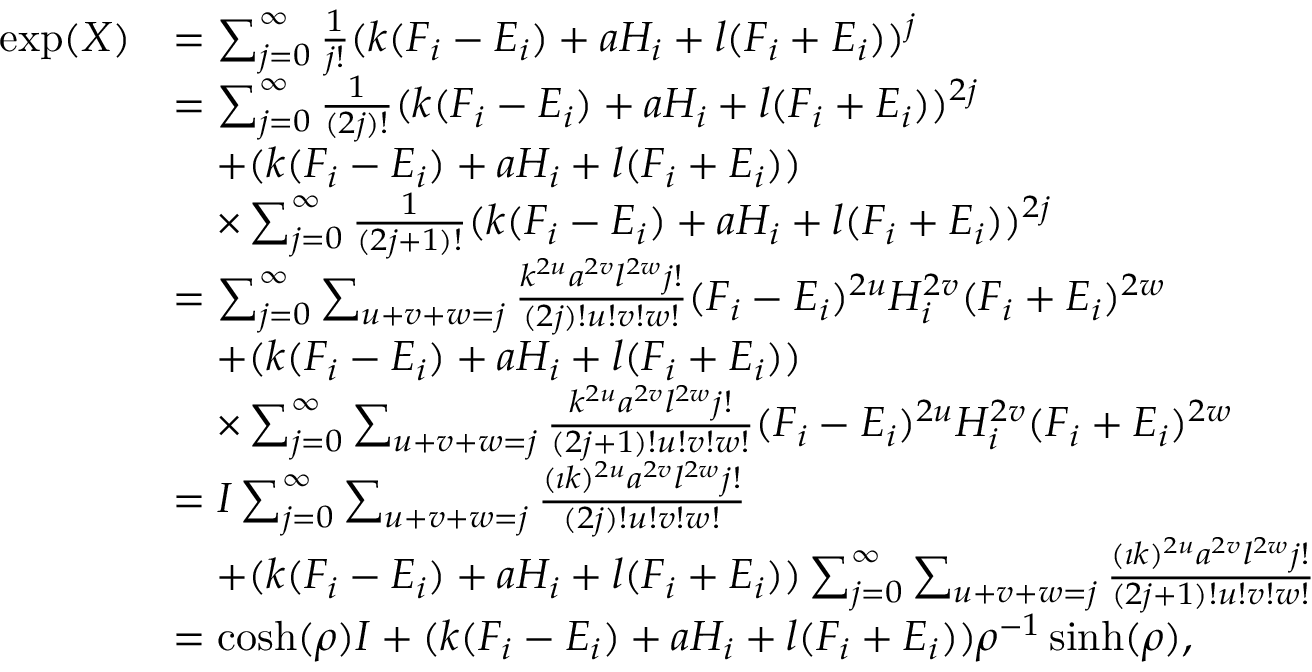Convert formula to latex. <formula><loc_0><loc_0><loc_500><loc_500>\begin{array} { r l } { \exp ( X ) } & { = \sum _ { j = 0 } ^ { \infty } \frac { 1 } { j ! } ( k ( F _ { i } - E _ { i } ) + a H _ { i } + l ( F _ { i } + E _ { i } ) ) ^ { j } } \\ & { = \sum _ { j = 0 } ^ { \infty } \frac { 1 } { ( 2 j ) ! } ( k ( F _ { i } - E _ { i } ) + a H _ { i } + l ( F _ { i } + E _ { i } ) ) ^ { 2 j } } \\ & { \quad + ( k ( F _ { i } - E _ { i } ) + a H _ { i } + l ( F _ { i } + E _ { i } ) ) } \\ & { \quad \times \sum _ { j = 0 } ^ { \infty } \frac { 1 } { ( 2 j + 1 ) ! } ( k ( F _ { i } - E _ { i } ) + a H _ { i } + l ( F _ { i } + E _ { i } ) ) ^ { 2 j } } \\ & { = \sum _ { j = 0 } ^ { \infty } \sum _ { u + v + w = j } \frac { k ^ { 2 u } a ^ { 2 v } l ^ { 2 w } j ! } { ( 2 j ) ! u ! v ! w ! } ( F _ { i } - E _ { i } ) ^ { 2 u } H _ { i } ^ { 2 v } ( F _ { i } + E _ { i } ) ^ { 2 w } } \\ & { \quad + ( k ( F _ { i } - E _ { i } ) + a H _ { i } + l ( F _ { i } + E _ { i } ) ) } \\ & { \quad \times \sum _ { j = 0 } ^ { \infty } \sum _ { u + v + w = j } \frac { k ^ { 2 u } a ^ { 2 v } l ^ { 2 w } j ! } { ( 2 j + 1 ) ! u ! v ! w ! } ( F _ { i } - E _ { i } ) ^ { 2 u } H _ { i } ^ { 2 v } ( F _ { i } + E _ { i } ) ^ { 2 w } } \\ & { = I \sum _ { j = 0 } ^ { \infty } \sum _ { u + v + w = j } \frac { ( \imath k ) ^ { 2 u } a ^ { 2 v } l ^ { 2 w } j ! } { ( 2 j ) ! u ! v ! w ! } } \\ & { \quad + ( k ( F _ { i } - E _ { i } ) + a H _ { i } + l ( F _ { i } + E _ { i } ) ) \sum _ { j = 0 } ^ { \infty } \sum _ { u + v + w = j } \frac { ( \imath k ) ^ { 2 u } a ^ { 2 v } l ^ { 2 w } j ! } { ( 2 j + 1 ) ! u ! v ! w ! } } \\ & { = \cosh ( \rho ) I + ( k ( F _ { i } - E _ { i } ) + a H _ { i } + l ( F _ { i } + E _ { i } ) ) \rho ^ { - 1 } \sinh ( \rho ) , } \end{array}</formula> 